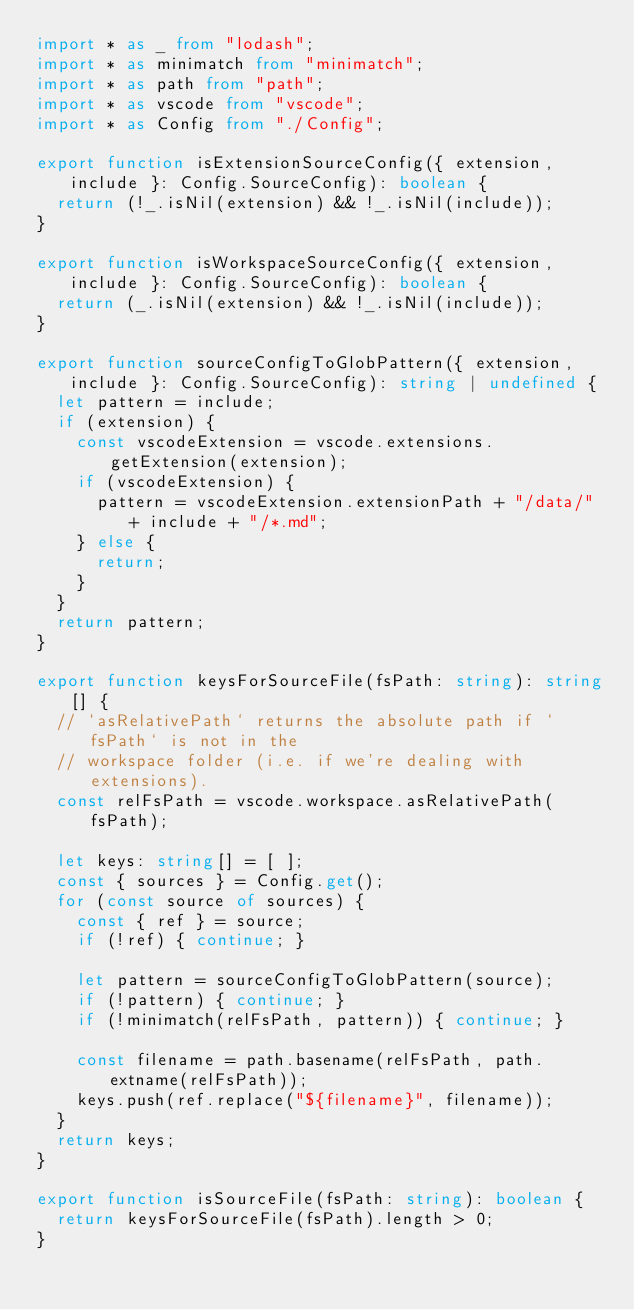<code> <loc_0><loc_0><loc_500><loc_500><_TypeScript_>import * as _ from "lodash";
import * as minimatch from "minimatch";
import * as path from "path";
import * as vscode from "vscode";
import * as Config from "./Config";

export function isExtensionSourceConfig({ extension, include }: Config.SourceConfig): boolean {
  return (!_.isNil(extension) && !_.isNil(include));
}

export function isWorkspaceSourceConfig({ extension, include }: Config.SourceConfig): boolean {
  return (_.isNil(extension) && !_.isNil(include));
}

export function sourceConfigToGlobPattern({ extension, include }: Config.SourceConfig): string | undefined {
  let pattern = include;
  if (extension) {
    const vscodeExtension = vscode.extensions.getExtension(extension);
    if (vscodeExtension) {
      pattern = vscodeExtension.extensionPath + "/data/" + include + "/*.md";
    } else {
      return;
    }
  }
  return pattern;
}

export function keysForSourceFile(fsPath: string): string[] {
  // `asRelativePath` returns the absolute path if `fsPath` is not in the
  // workspace folder (i.e. if we're dealing with extensions).
  const relFsPath = vscode.workspace.asRelativePath(fsPath);

  let keys: string[] = [ ];
  const { sources } = Config.get();
  for (const source of sources) {
    const { ref } = source;
    if (!ref) { continue; }

    let pattern = sourceConfigToGlobPattern(source);
    if (!pattern) { continue; }
    if (!minimatch(relFsPath, pattern)) { continue; }

    const filename = path.basename(relFsPath, path.extname(relFsPath));
    keys.push(ref.replace("${filename}", filename));
  }
  return keys;
}

export function isSourceFile(fsPath: string): boolean {
  return keysForSourceFile(fsPath).length > 0;
}</code> 